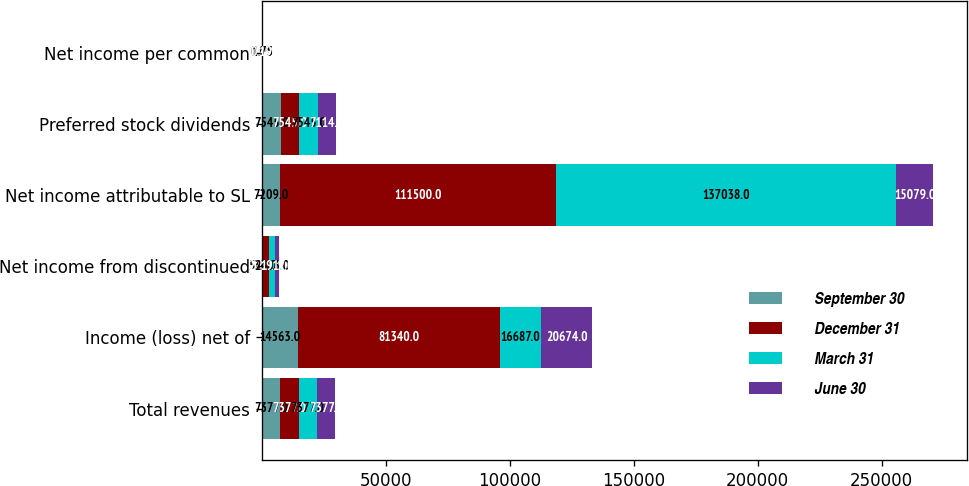Convert chart to OTSL. <chart><loc_0><loc_0><loc_500><loc_500><stacked_bar_chart><ecel><fcel>Total revenues<fcel>Income (loss) net of<fcel>Net income from discontinued<fcel>Net income attributable to SL<fcel>Preferred stock dividends<fcel>Net income per common<nl><fcel>September 30<fcel>7377<fcel>14563<fcel>533<fcel>7209<fcel>7545<fcel>0.09<nl><fcel>December 31<fcel>7377<fcel>81340<fcel>2211<fcel>111500<fcel>7545<fcel>1.42<nl><fcel>March 31<fcel>7377<fcel>16687<fcel>2403<fcel>137038<fcel>7545<fcel>1.75<nl><fcel>June 30<fcel>7377<fcel>20674<fcel>1917<fcel>15079<fcel>7114<fcel>0.19<nl></chart> 